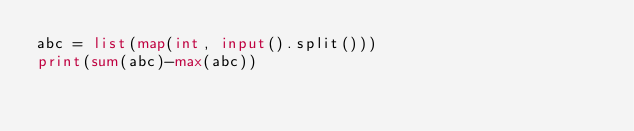Convert code to text. <code><loc_0><loc_0><loc_500><loc_500><_Python_>abc = list(map(int, input().split()))
print(sum(abc)-max(abc))
</code> 